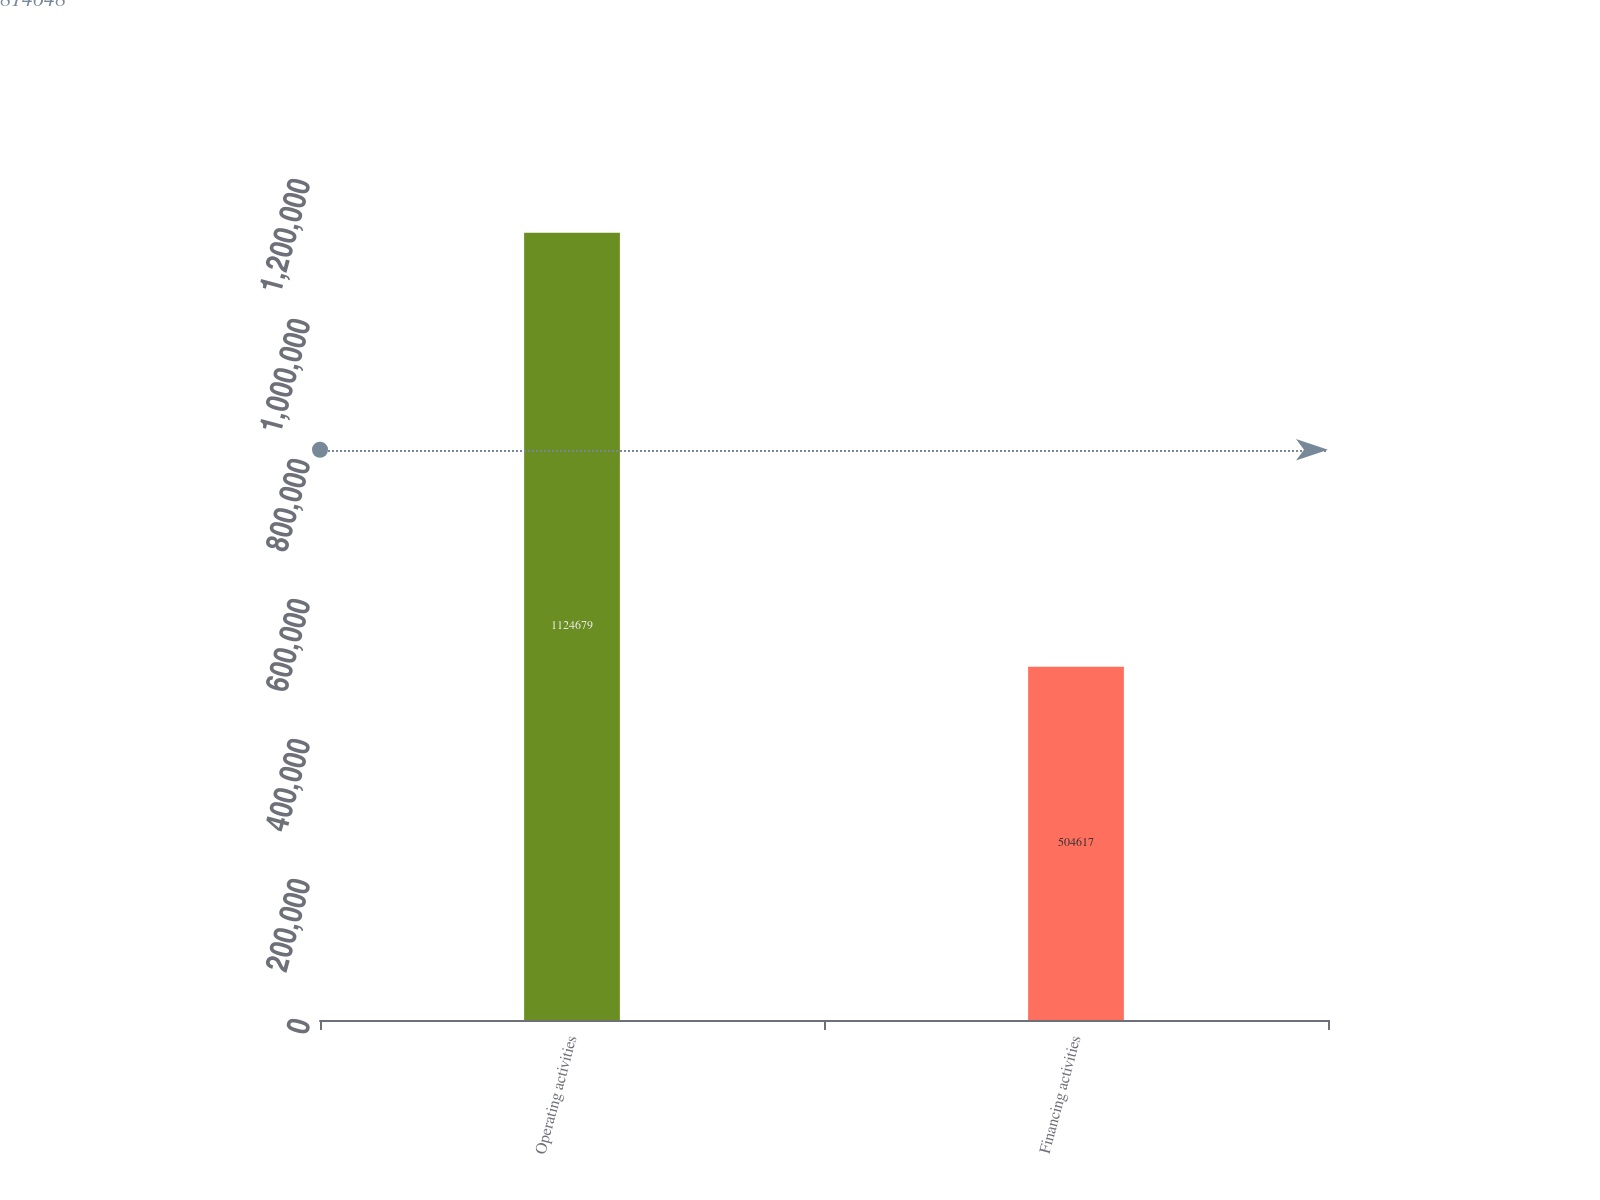<chart> <loc_0><loc_0><loc_500><loc_500><bar_chart><fcel>Operating activities<fcel>Financing activities<nl><fcel>1.12468e+06<fcel>504617<nl></chart> 